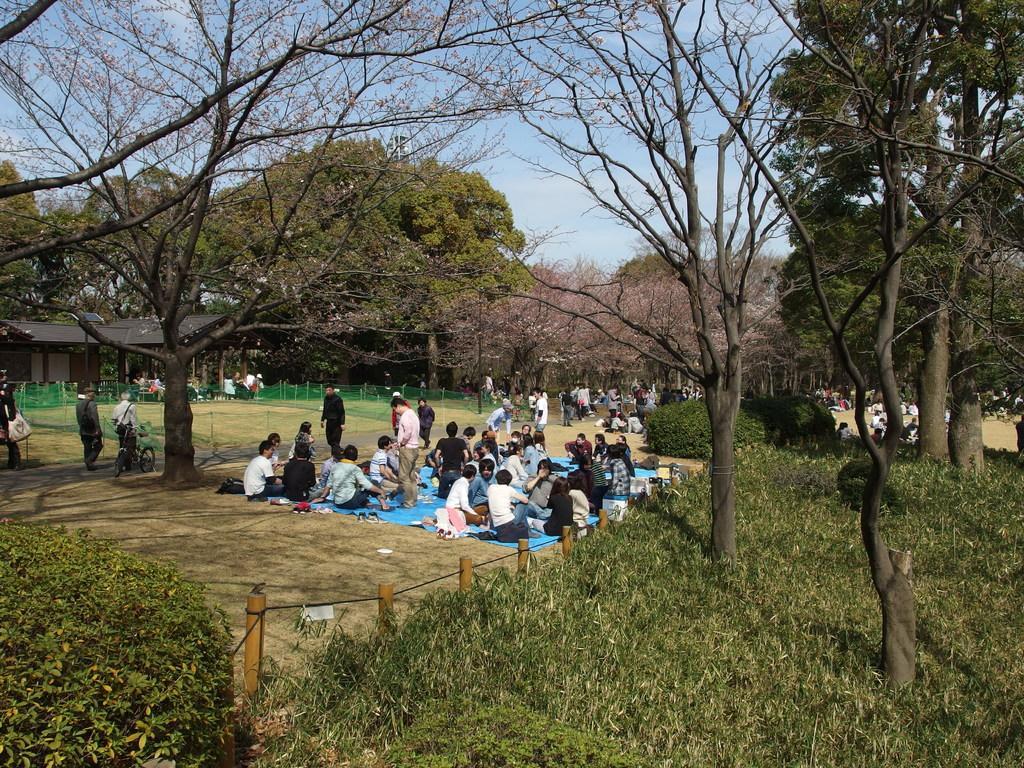Please provide a concise description of this image. In this image we can see group of people and few of them are sitting. Here we can see plants, mesh, sheds, and trees. In the background there is sky. 